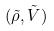Convert formula to latex. <formula><loc_0><loc_0><loc_500><loc_500>( \tilde { \rho } , \tilde { V } )</formula> 